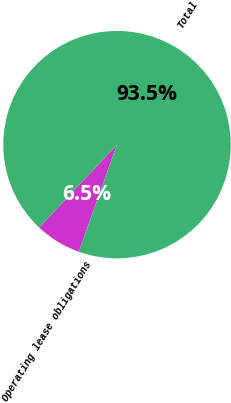Convert chart to OTSL. <chart><loc_0><loc_0><loc_500><loc_500><pie_chart><fcel>Operating lease obligations<fcel>Total<nl><fcel>6.54%<fcel>93.46%<nl></chart> 